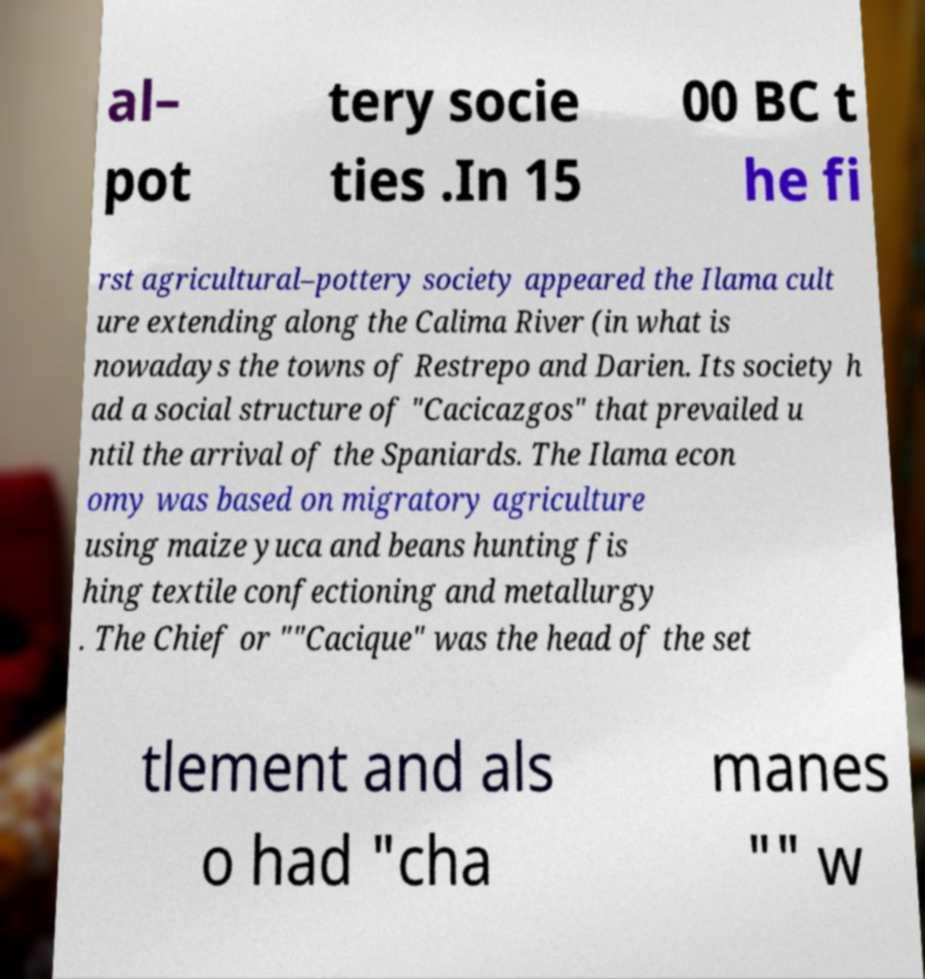Could you extract and type out the text from this image? al– pot tery socie ties .In 15 00 BC t he fi rst agricultural–pottery society appeared the Ilama cult ure extending along the Calima River (in what is nowadays the towns of Restrepo and Darien. Its society h ad a social structure of "Cacicazgos" that prevailed u ntil the arrival of the Spaniards. The Ilama econ omy was based on migratory agriculture using maize yuca and beans hunting fis hing textile confectioning and metallurgy . The Chief or ""Cacique" was the head of the set tlement and als o had "cha manes "" w 